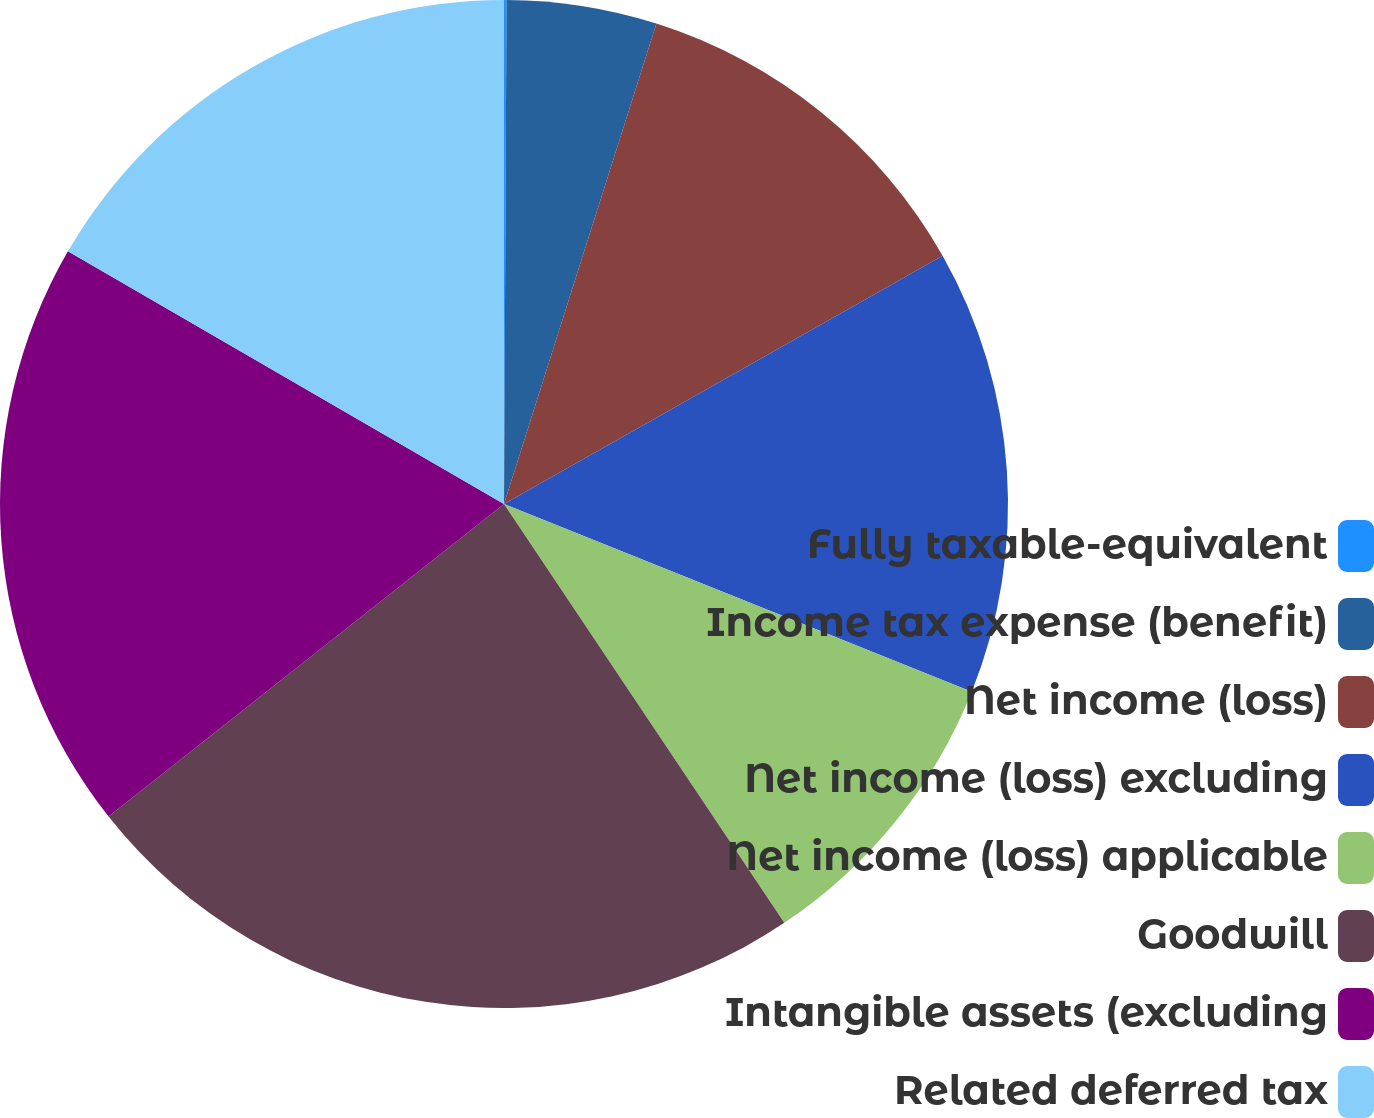<chart> <loc_0><loc_0><loc_500><loc_500><pie_chart><fcel>Fully taxable-equivalent<fcel>Income tax expense (benefit)<fcel>Net income (loss)<fcel>Net income (loss) excluding<fcel>Net income (loss) applicable<fcel>Goodwill<fcel>Intangible assets (excluding<fcel>Related deferred tax<nl><fcel>0.08%<fcel>4.81%<fcel>11.91%<fcel>14.27%<fcel>9.54%<fcel>23.74%<fcel>19.0%<fcel>16.64%<nl></chart> 